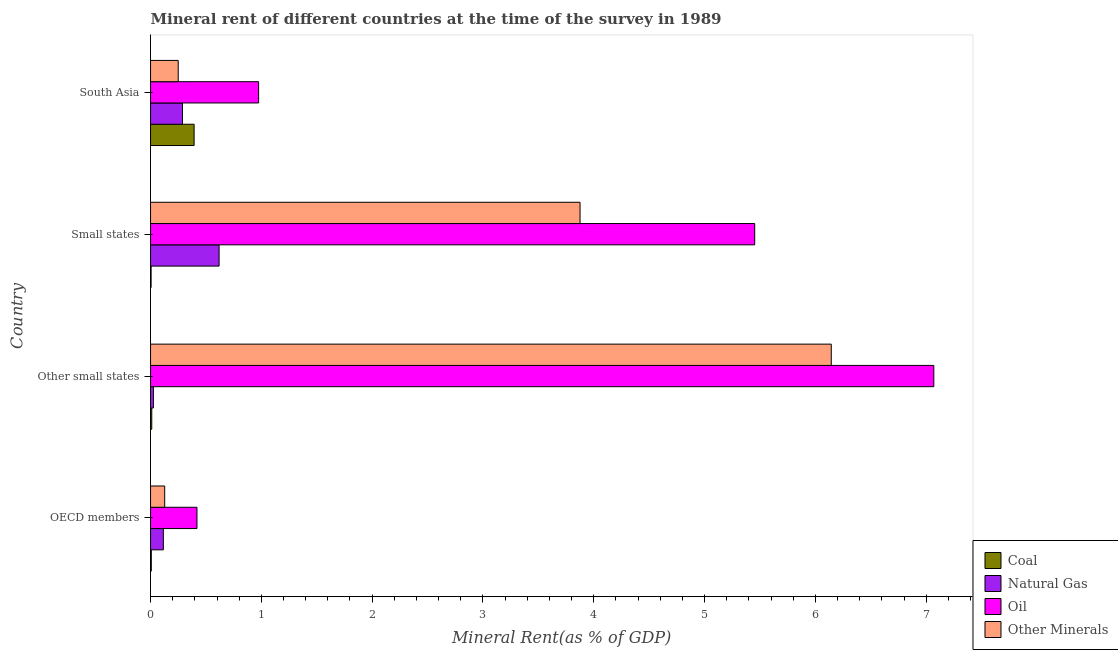How many different coloured bars are there?
Ensure brevity in your answer.  4. Are the number of bars on each tick of the Y-axis equal?
Give a very brief answer. Yes. How many bars are there on the 3rd tick from the bottom?
Ensure brevity in your answer.  4. What is the label of the 3rd group of bars from the top?
Ensure brevity in your answer.  Other small states. In how many cases, is the number of bars for a given country not equal to the number of legend labels?
Offer a terse response. 0. What is the natural gas rent in OECD members?
Provide a succinct answer. 0.12. Across all countries, what is the maximum coal rent?
Your response must be concise. 0.39. Across all countries, what is the minimum natural gas rent?
Provide a short and direct response. 0.03. In which country was the natural gas rent maximum?
Offer a terse response. Small states. In which country was the natural gas rent minimum?
Make the answer very short. Other small states. What is the total coal rent in the graph?
Your answer should be compact. 0.42. What is the difference between the oil rent in OECD members and that in South Asia?
Your answer should be very brief. -0.56. What is the difference between the  rent of other minerals in OECD members and the coal rent in Other small states?
Offer a terse response. 0.12. What is the average oil rent per country?
Provide a short and direct response. 3.48. What is the difference between the natural gas rent and oil rent in OECD members?
Keep it short and to the point. -0.3. In how many countries, is the natural gas rent greater than 3.6 %?
Your answer should be very brief. 0. What is the ratio of the oil rent in OECD members to that in Small states?
Your answer should be compact. 0.08. Is the difference between the oil rent in Other small states and Small states greater than the difference between the  rent of other minerals in Other small states and Small states?
Give a very brief answer. No. What is the difference between the highest and the second highest oil rent?
Provide a short and direct response. 1.62. What is the difference between the highest and the lowest natural gas rent?
Your answer should be very brief. 0.59. Is it the case that in every country, the sum of the oil rent and  rent of other minerals is greater than the sum of coal rent and natural gas rent?
Keep it short and to the point. No. What does the 1st bar from the top in Small states represents?
Your answer should be compact. Other Minerals. What does the 3rd bar from the bottom in Small states represents?
Offer a very short reply. Oil. Is it the case that in every country, the sum of the coal rent and natural gas rent is greater than the oil rent?
Offer a terse response. No. How many bars are there?
Provide a short and direct response. 16. What is the difference between two consecutive major ticks on the X-axis?
Offer a very short reply. 1. Does the graph contain any zero values?
Ensure brevity in your answer.  No. How many legend labels are there?
Ensure brevity in your answer.  4. How are the legend labels stacked?
Your answer should be compact. Vertical. What is the title of the graph?
Offer a very short reply. Mineral rent of different countries at the time of the survey in 1989. What is the label or title of the X-axis?
Keep it short and to the point. Mineral Rent(as % of GDP). What is the Mineral Rent(as % of GDP) of Coal in OECD members?
Ensure brevity in your answer.  0.01. What is the Mineral Rent(as % of GDP) of Natural Gas in OECD members?
Provide a short and direct response. 0.12. What is the Mineral Rent(as % of GDP) of Oil in OECD members?
Provide a succinct answer. 0.42. What is the Mineral Rent(as % of GDP) in Other Minerals in OECD members?
Offer a terse response. 0.13. What is the Mineral Rent(as % of GDP) of Coal in Other small states?
Make the answer very short. 0.01. What is the Mineral Rent(as % of GDP) of Natural Gas in Other small states?
Your response must be concise. 0.03. What is the Mineral Rent(as % of GDP) in Oil in Other small states?
Provide a succinct answer. 7.07. What is the Mineral Rent(as % of GDP) in Other Minerals in Other small states?
Ensure brevity in your answer.  6.14. What is the Mineral Rent(as % of GDP) of Coal in Small states?
Provide a succinct answer. 0.01. What is the Mineral Rent(as % of GDP) in Natural Gas in Small states?
Your response must be concise. 0.62. What is the Mineral Rent(as % of GDP) in Oil in Small states?
Your answer should be very brief. 5.45. What is the Mineral Rent(as % of GDP) of Other Minerals in Small states?
Ensure brevity in your answer.  3.88. What is the Mineral Rent(as % of GDP) in Coal in South Asia?
Offer a terse response. 0.39. What is the Mineral Rent(as % of GDP) in Natural Gas in South Asia?
Give a very brief answer. 0.29. What is the Mineral Rent(as % of GDP) in Oil in South Asia?
Keep it short and to the point. 0.98. What is the Mineral Rent(as % of GDP) of Other Minerals in South Asia?
Offer a terse response. 0.25. Across all countries, what is the maximum Mineral Rent(as % of GDP) of Coal?
Give a very brief answer. 0.39. Across all countries, what is the maximum Mineral Rent(as % of GDP) in Natural Gas?
Keep it short and to the point. 0.62. Across all countries, what is the maximum Mineral Rent(as % of GDP) of Oil?
Your answer should be compact. 7.07. Across all countries, what is the maximum Mineral Rent(as % of GDP) of Other Minerals?
Keep it short and to the point. 6.14. Across all countries, what is the minimum Mineral Rent(as % of GDP) of Coal?
Make the answer very short. 0.01. Across all countries, what is the minimum Mineral Rent(as % of GDP) in Natural Gas?
Offer a very short reply. 0.03. Across all countries, what is the minimum Mineral Rent(as % of GDP) of Oil?
Offer a terse response. 0.42. Across all countries, what is the minimum Mineral Rent(as % of GDP) of Other Minerals?
Make the answer very short. 0.13. What is the total Mineral Rent(as % of GDP) in Coal in the graph?
Offer a very short reply. 0.42. What is the total Mineral Rent(as % of GDP) of Natural Gas in the graph?
Your answer should be compact. 1.05. What is the total Mineral Rent(as % of GDP) of Oil in the graph?
Make the answer very short. 13.92. What is the total Mineral Rent(as % of GDP) in Other Minerals in the graph?
Provide a short and direct response. 10.4. What is the difference between the Mineral Rent(as % of GDP) in Coal in OECD members and that in Other small states?
Keep it short and to the point. -0. What is the difference between the Mineral Rent(as % of GDP) in Natural Gas in OECD members and that in Other small states?
Offer a very short reply. 0.09. What is the difference between the Mineral Rent(as % of GDP) in Oil in OECD members and that in Other small states?
Offer a very short reply. -6.65. What is the difference between the Mineral Rent(as % of GDP) of Other Minerals in OECD members and that in Other small states?
Make the answer very short. -6.02. What is the difference between the Mineral Rent(as % of GDP) in Coal in OECD members and that in Small states?
Give a very brief answer. 0. What is the difference between the Mineral Rent(as % of GDP) in Natural Gas in OECD members and that in Small states?
Your answer should be compact. -0.5. What is the difference between the Mineral Rent(as % of GDP) of Oil in OECD members and that in Small states?
Provide a short and direct response. -5.03. What is the difference between the Mineral Rent(as % of GDP) of Other Minerals in OECD members and that in Small states?
Offer a very short reply. -3.75. What is the difference between the Mineral Rent(as % of GDP) in Coal in OECD members and that in South Asia?
Ensure brevity in your answer.  -0.39. What is the difference between the Mineral Rent(as % of GDP) of Natural Gas in OECD members and that in South Asia?
Your response must be concise. -0.17. What is the difference between the Mineral Rent(as % of GDP) in Oil in OECD members and that in South Asia?
Ensure brevity in your answer.  -0.56. What is the difference between the Mineral Rent(as % of GDP) in Other Minerals in OECD members and that in South Asia?
Give a very brief answer. -0.12. What is the difference between the Mineral Rent(as % of GDP) in Coal in Other small states and that in Small states?
Make the answer very short. 0.01. What is the difference between the Mineral Rent(as % of GDP) of Natural Gas in Other small states and that in Small states?
Provide a succinct answer. -0.59. What is the difference between the Mineral Rent(as % of GDP) in Oil in Other small states and that in Small states?
Make the answer very short. 1.62. What is the difference between the Mineral Rent(as % of GDP) of Other Minerals in Other small states and that in Small states?
Ensure brevity in your answer.  2.27. What is the difference between the Mineral Rent(as % of GDP) in Coal in Other small states and that in South Asia?
Give a very brief answer. -0.38. What is the difference between the Mineral Rent(as % of GDP) in Natural Gas in Other small states and that in South Asia?
Your answer should be very brief. -0.26. What is the difference between the Mineral Rent(as % of GDP) in Oil in Other small states and that in South Asia?
Give a very brief answer. 6.09. What is the difference between the Mineral Rent(as % of GDP) in Other Minerals in Other small states and that in South Asia?
Provide a succinct answer. 5.89. What is the difference between the Mineral Rent(as % of GDP) in Coal in Small states and that in South Asia?
Ensure brevity in your answer.  -0.39. What is the difference between the Mineral Rent(as % of GDP) of Natural Gas in Small states and that in South Asia?
Make the answer very short. 0.33. What is the difference between the Mineral Rent(as % of GDP) in Oil in Small states and that in South Asia?
Your response must be concise. 4.48. What is the difference between the Mineral Rent(as % of GDP) in Other Minerals in Small states and that in South Asia?
Your answer should be compact. 3.63. What is the difference between the Mineral Rent(as % of GDP) in Coal in OECD members and the Mineral Rent(as % of GDP) in Natural Gas in Other small states?
Provide a succinct answer. -0.02. What is the difference between the Mineral Rent(as % of GDP) of Coal in OECD members and the Mineral Rent(as % of GDP) of Oil in Other small states?
Keep it short and to the point. -7.06. What is the difference between the Mineral Rent(as % of GDP) of Coal in OECD members and the Mineral Rent(as % of GDP) of Other Minerals in Other small states?
Keep it short and to the point. -6.14. What is the difference between the Mineral Rent(as % of GDP) in Natural Gas in OECD members and the Mineral Rent(as % of GDP) in Oil in Other small states?
Keep it short and to the point. -6.95. What is the difference between the Mineral Rent(as % of GDP) of Natural Gas in OECD members and the Mineral Rent(as % of GDP) of Other Minerals in Other small states?
Your response must be concise. -6.03. What is the difference between the Mineral Rent(as % of GDP) in Oil in OECD members and the Mineral Rent(as % of GDP) in Other Minerals in Other small states?
Your response must be concise. -5.72. What is the difference between the Mineral Rent(as % of GDP) of Coal in OECD members and the Mineral Rent(as % of GDP) of Natural Gas in Small states?
Make the answer very short. -0.61. What is the difference between the Mineral Rent(as % of GDP) of Coal in OECD members and the Mineral Rent(as % of GDP) of Oil in Small states?
Offer a very short reply. -5.45. What is the difference between the Mineral Rent(as % of GDP) in Coal in OECD members and the Mineral Rent(as % of GDP) in Other Minerals in Small states?
Make the answer very short. -3.87. What is the difference between the Mineral Rent(as % of GDP) in Natural Gas in OECD members and the Mineral Rent(as % of GDP) in Oil in Small states?
Provide a succinct answer. -5.34. What is the difference between the Mineral Rent(as % of GDP) in Natural Gas in OECD members and the Mineral Rent(as % of GDP) in Other Minerals in Small states?
Your answer should be compact. -3.76. What is the difference between the Mineral Rent(as % of GDP) in Oil in OECD members and the Mineral Rent(as % of GDP) in Other Minerals in Small states?
Provide a succinct answer. -3.46. What is the difference between the Mineral Rent(as % of GDP) in Coal in OECD members and the Mineral Rent(as % of GDP) in Natural Gas in South Asia?
Offer a terse response. -0.28. What is the difference between the Mineral Rent(as % of GDP) of Coal in OECD members and the Mineral Rent(as % of GDP) of Oil in South Asia?
Offer a very short reply. -0.97. What is the difference between the Mineral Rent(as % of GDP) in Coal in OECD members and the Mineral Rent(as % of GDP) in Other Minerals in South Asia?
Provide a succinct answer. -0.24. What is the difference between the Mineral Rent(as % of GDP) of Natural Gas in OECD members and the Mineral Rent(as % of GDP) of Oil in South Asia?
Ensure brevity in your answer.  -0.86. What is the difference between the Mineral Rent(as % of GDP) of Natural Gas in OECD members and the Mineral Rent(as % of GDP) of Other Minerals in South Asia?
Your answer should be very brief. -0.13. What is the difference between the Mineral Rent(as % of GDP) in Oil in OECD members and the Mineral Rent(as % of GDP) in Other Minerals in South Asia?
Provide a short and direct response. 0.17. What is the difference between the Mineral Rent(as % of GDP) of Coal in Other small states and the Mineral Rent(as % of GDP) of Natural Gas in Small states?
Offer a terse response. -0.61. What is the difference between the Mineral Rent(as % of GDP) of Coal in Other small states and the Mineral Rent(as % of GDP) of Oil in Small states?
Keep it short and to the point. -5.44. What is the difference between the Mineral Rent(as % of GDP) of Coal in Other small states and the Mineral Rent(as % of GDP) of Other Minerals in Small states?
Provide a short and direct response. -3.87. What is the difference between the Mineral Rent(as % of GDP) in Natural Gas in Other small states and the Mineral Rent(as % of GDP) in Oil in Small states?
Offer a very short reply. -5.43. What is the difference between the Mineral Rent(as % of GDP) of Natural Gas in Other small states and the Mineral Rent(as % of GDP) of Other Minerals in Small states?
Keep it short and to the point. -3.85. What is the difference between the Mineral Rent(as % of GDP) in Oil in Other small states and the Mineral Rent(as % of GDP) in Other Minerals in Small states?
Ensure brevity in your answer.  3.19. What is the difference between the Mineral Rent(as % of GDP) of Coal in Other small states and the Mineral Rent(as % of GDP) of Natural Gas in South Asia?
Offer a terse response. -0.28. What is the difference between the Mineral Rent(as % of GDP) of Coal in Other small states and the Mineral Rent(as % of GDP) of Oil in South Asia?
Make the answer very short. -0.96. What is the difference between the Mineral Rent(as % of GDP) in Coal in Other small states and the Mineral Rent(as % of GDP) in Other Minerals in South Asia?
Provide a short and direct response. -0.24. What is the difference between the Mineral Rent(as % of GDP) of Natural Gas in Other small states and the Mineral Rent(as % of GDP) of Oil in South Asia?
Keep it short and to the point. -0.95. What is the difference between the Mineral Rent(as % of GDP) in Natural Gas in Other small states and the Mineral Rent(as % of GDP) in Other Minerals in South Asia?
Offer a very short reply. -0.22. What is the difference between the Mineral Rent(as % of GDP) of Oil in Other small states and the Mineral Rent(as % of GDP) of Other Minerals in South Asia?
Ensure brevity in your answer.  6.82. What is the difference between the Mineral Rent(as % of GDP) in Coal in Small states and the Mineral Rent(as % of GDP) in Natural Gas in South Asia?
Give a very brief answer. -0.28. What is the difference between the Mineral Rent(as % of GDP) of Coal in Small states and the Mineral Rent(as % of GDP) of Oil in South Asia?
Ensure brevity in your answer.  -0.97. What is the difference between the Mineral Rent(as % of GDP) in Coal in Small states and the Mineral Rent(as % of GDP) in Other Minerals in South Asia?
Your response must be concise. -0.24. What is the difference between the Mineral Rent(as % of GDP) of Natural Gas in Small states and the Mineral Rent(as % of GDP) of Oil in South Asia?
Your answer should be compact. -0.36. What is the difference between the Mineral Rent(as % of GDP) of Natural Gas in Small states and the Mineral Rent(as % of GDP) of Other Minerals in South Asia?
Offer a very short reply. 0.37. What is the difference between the Mineral Rent(as % of GDP) in Oil in Small states and the Mineral Rent(as % of GDP) in Other Minerals in South Asia?
Keep it short and to the point. 5.2. What is the average Mineral Rent(as % of GDP) of Coal per country?
Give a very brief answer. 0.1. What is the average Mineral Rent(as % of GDP) in Natural Gas per country?
Keep it short and to the point. 0.26. What is the average Mineral Rent(as % of GDP) in Oil per country?
Your response must be concise. 3.48. What is the average Mineral Rent(as % of GDP) in Other Minerals per country?
Offer a terse response. 2.6. What is the difference between the Mineral Rent(as % of GDP) in Coal and Mineral Rent(as % of GDP) in Natural Gas in OECD members?
Offer a very short reply. -0.11. What is the difference between the Mineral Rent(as % of GDP) in Coal and Mineral Rent(as % of GDP) in Oil in OECD members?
Give a very brief answer. -0.41. What is the difference between the Mineral Rent(as % of GDP) in Coal and Mineral Rent(as % of GDP) in Other Minerals in OECD members?
Offer a very short reply. -0.12. What is the difference between the Mineral Rent(as % of GDP) in Natural Gas and Mineral Rent(as % of GDP) in Oil in OECD members?
Your answer should be compact. -0.3. What is the difference between the Mineral Rent(as % of GDP) in Natural Gas and Mineral Rent(as % of GDP) in Other Minerals in OECD members?
Provide a short and direct response. -0.01. What is the difference between the Mineral Rent(as % of GDP) in Oil and Mineral Rent(as % of GDP) in Other Minerals in OECD members?
Provide a short and direct response. 0.29. What is the difference between the Mineral Rent(as % of GDP) in Coal and Mineral Rent(as % of GDP) in Natural Gas in Other small states?
Provide a succinct answer. -0.01. What is the difference between the Mineral Rent(as % of GDP) in Coal and Mineral Rent(as % of GDP) in Oil in Other small states?
Ensure brevity in your answer.  -7.06. What is the difference between the Mineral Rent(as % of GDP) of Coal and Mineral Rent(as % of GDP) of Other Minerals in Other small states?
Provide a succinct answer. -6.13. What is the difference between the Mineral Rent(as % of GDP) of Natural Gas and Mineral Rent(as % of GDP) of Oil in Other small states?
Keep it short and to the point. -7.04. What is the difference between the Mineral Rent(as % of GDP) of Natural Gas and Mineral Rent(as % of GDP) of Other Minerals in Other small states?
Provide a short and direct response. -6.12. What is the difference between the Mineral Rent(as % of GDP) in Oil and Mineral Rent(as % of GDP) in Other Minerals in Other small states?
Offer a very short reply. 0.93. What is the difference between the Mineral Rent(as % of GDP) of Coal and Mineral Rent(as % of GDP) of Natural Gas in Small states?
Make the answer very short. -0.61. What is the difference between the Mineral Rent(as % of GDP) of Coal and Mineral Rent(as % of GDP) of Oil in Small states?
Provide a short and direct response. -5.45. What is the difference between the Mineral Rent(as % of GDP) of Coal and Mineral Rent(as % of GDP) of Other Minerals in Small states?
Give a very brief answer. -3.87. What is the difference between the Mineral Rent(as % of GDP) in Natural Gas and Mineral Rent(as % of GDP) in Oil in Small states?
Your answer should be very brief. -4.83. What is the difference between the Mineral Rent(as % of GDP) in Natural Gas and Mineral Rent(as % of GDP) in Other Minerals in Small states?
Offer a terse response. -3.26. What is the difference between the Mineral Rent(as % of GDP) of Oil and Mineral Rent(as % of GDP) of Other Minerals in Small states?
Your response must be concise. 1.58. What is the difference between the Mineral Rent(as % of GDP) in Coal and Mineral Rent(as % of GDP) in Natural Gas in South Asia?
Provide a short and direct response. 0.1. What is the difference between the Mineral Rent(as % of GDP) of Coal and Mineral Rent(as % of GDP) of Oil in South Asia?
Your answer should be very brief. -0.58. What is the difference between the Mineral Rent(as % of GDP) in Coal and Mineral Rent(as % of GDP) in Other Minerals in South Asia?
Give a very brief answer. 0.14. What is the difference between the Mineral Rent(as % of GDP) of Natural Gas and Mineral Rent(as % of GDP) of Oil in South Asia?
Provide a succinct answer. -0.69. What is the difference between the Mineral Rent(as % of GDP) of Natural Gas and Mineral Rent(as % of GDP) of Other Minerals in South Asia?
Make the answer very short. 0.04. What is the difference between the Mineral Rent(as % of GDP) in Oil and Mineral Rent(as % of GDP) in Other Minerals in South Asia?
Your answer should be compact. 0.73. What is the ratio of the Mineral Rent(as % of GDP) of Coal in OECD members to that in Other small states?
Ensure brevity in your answer.  0.62. What is the ratio of the Mineral Rent(as % of GDP) of Natural Gas in OECD members to that in Other small states?
Make the answer very short. 4.48. What is the ratio of the Mineral Rent(as % of GDP) in Oil in OECD members to that in Other small states?
Offer a terse response. 0.06. What is the ratio of the Mineral Rent(as % of GDP) in Other Minerals in OECD members to that in Other small states?
Offer a very short reply. 0.02. What is the ratio of the Mineral Rent(as % of GDP) of Coal in OECD members to that in Small states?
Give a very brief answer. 1.37. What is the ratio of the Mineral Rent(as % of GDP) in Natural Gas in OECD members to that in Small states?
Keep it short and to the point. 0.19. What is the ratio of the Mineral Rent(as % of GDP) of Oil in OECD members to that in Small states?
Ensure brevity in your answer.  0.08. What is the ratio of the Mineral Rent(as % of GDP) of Other Minerals in OECD members to that in Small states?
Give a very brief answer. 0.03. What is the ratio of the Mineral Rent(as % of GDP) of Coal in OECD members to that in South Asia?
Your answer should be compact. 0.02. What is the ratio of the Mineral Rent(as % of GDP) of Natural Gas in OECD members to that in South Asia?
Your answer should be very brief. 0.4. What is the ratio of the Mineral Rent(as % of GDP) in Oil in OECD members to that in South Asia?
Your answer should be compact. 0.43. What is the ratio of the Mineral Rent(as % of GDP) of Other Minerals in OECD members to that in South Asia?
Offer a very short reply. 0.51. What is the ratio of the Mineral Rent(as % of GDP) in Coal in Other small states to that in Small states?
Provide a short and direct response. 2.21. What is the ratio of the Mineral Rent(as % of GDP) of Natural Gas in Other small states to that in Small states?
Offer a very short reply. 0.04. What is the ratio of the Mineral Rent(as % of GDP) of Oil in Other small states to that in Small states?
Give a very brief answer. 1.3. What is the ratio of the Mineral Rent(as % of GDP) in Other Minerals in Other small states to that in Small states?
Your answer should be compact. 1.58. What is the ratio of the Mineral Rent(as % of GDP) in Coal in Other small states to that in South Asia?
Offer a very short reply. 0.03. What is the ratio of the Mineral Rent(as % of GDP) of Natural Gas in Other small states to that in South Asia?
Your answer should be very brief. 0.09. What is the ratio of the Mineral Rent(as % of GDP) in Oil in Other small states to that in South Asia?
Your answer should be very brief. 7.25. What is the ratio of the Mineral Rent(as % of GDP) in Other Minerals in Other small states to that in South Asia?
Provide a short and direct response. 24.59. What is the ratio of the Mineral Rent(as % of GDP) of Coal in Small states to that in South Asia?
Provide a succinct answer. 0.01. What is the ratio of the Mineral Rent(as % of GDP) in Natural Gas in Small states to that in South Asia?
Offer a very short reply. 2.15. What is the ratio of the Mineral Rent(as % of GDP) of Oil in Small states to that in South Asia?
Your answer should be very brief. 5.59. What is the ratio of the Mineral Rent(as % of GDP) in Other Minerals in Small states to that in South Asia?
Offer a terse response. 15.51. What is the difference between the highest and the second highest Mineral Rent(as % of GDP) of Coal?
Your response must be concise. 0.38. What is the difference between the highest and the second highest Mineral Rent(as % of GDP) in Natural Gas?
Provide a succinct answer. 0.33. What is the difference between the highest and the second highest Mineral Rent(as % of GDP) in Oil?
Provide a succinct answer. 1.62. What is the difference between the highest and the second highest Mineral Rent(as % of GDP) of Other Minerals?
Keep it short and to the point. 2.27. What is the difference between the highest and the lowest Mineral Rent(as % of GDP) of Coal?
Keep it short and to the point. 0.39. What is the difference between the highest and the lowest Mineral Rent(as % of GDP) of Natural Gas?
Your answer should be compact. 0.59. What is the difference between the highest and the lowest Mineral Rent(as % of GDP) in Oil?
Make the answer very short. 6.65. What is the difference between the highest and the lowest Mineral Rent(as % of GDP) of Other Minerals?
Make the answer very short. 6.02. 